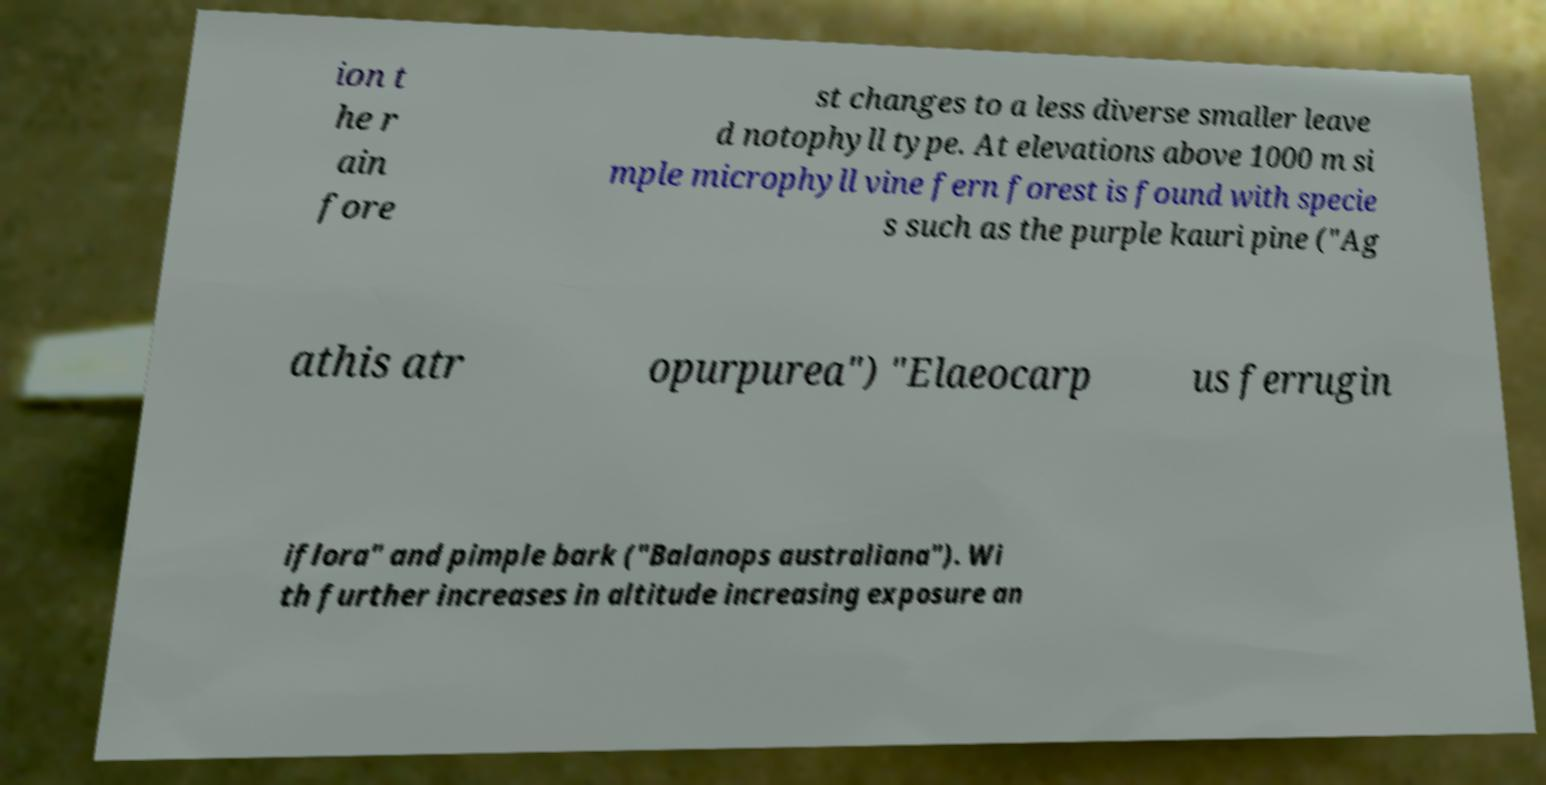Could you assist in decoding the text presented in this image and type it out clearly? ion t he r ain fore st changes to a less diverse smaller leave d notophyll type. At elevations above 1000 m si mple microphyll vine fern forest is found with specie s such as the purple kauri pine ("Ag athis atr opurpurea") "Elaeocarp us ferrugin iflora" and pimple bark ("Balanops australiana"). Wi th further increases in altitude increasing exposure an 